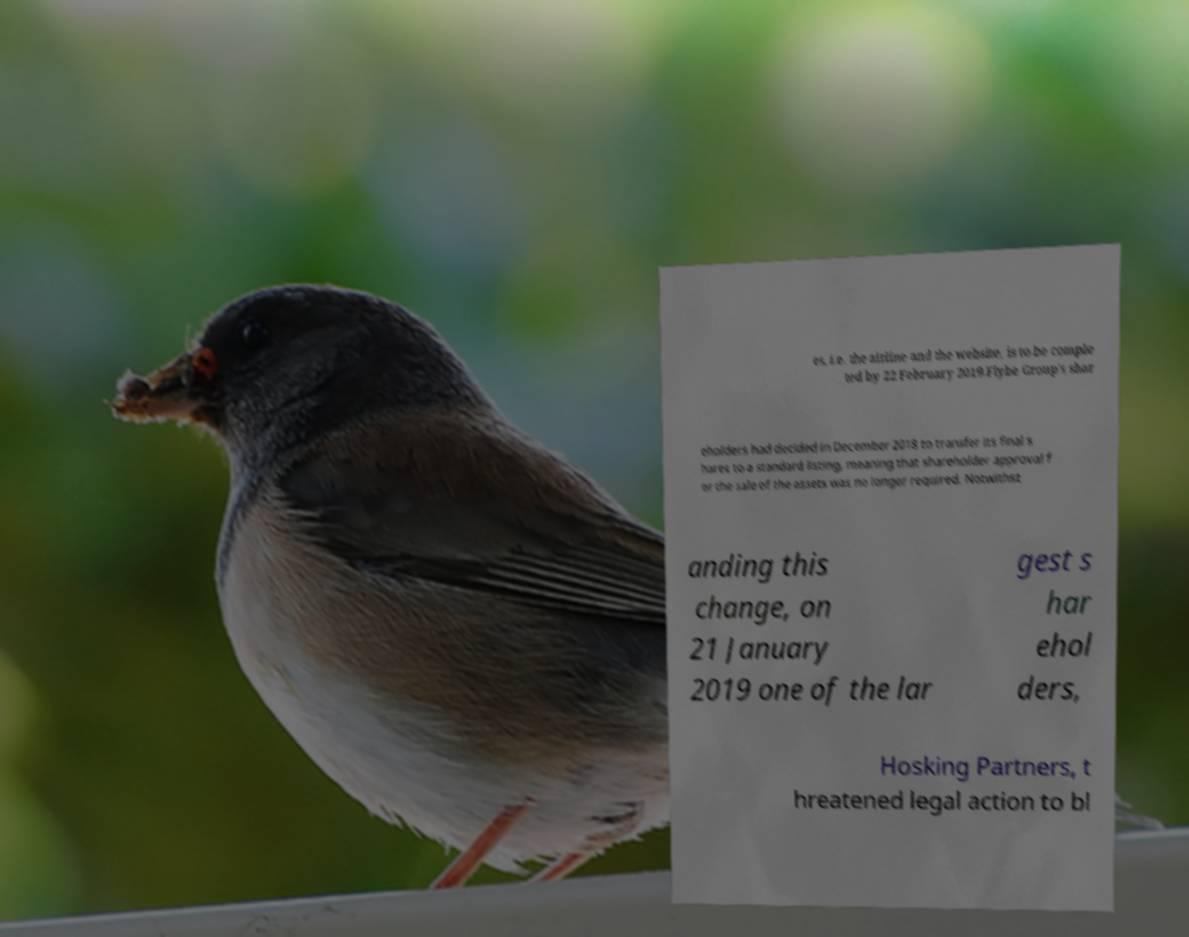Can you accurately transcribe the text from the provided image for me? es, i.e. the airline and the website, is to be comple ted by 22 February 2019.Flybe Group's shar eholders had decided in December 2018 to transfer its final s hares to a standard listing, meaning that shareholder approval f or the sale of the assets was no longer required. Notwithst anding this change, on 21 January 2019 one of the lar gest s har ehol ders, Hosking Partners, t hreatened legal action to bl 